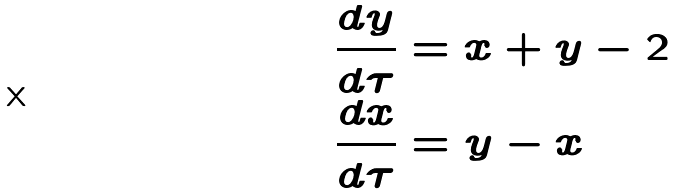Convert formula to latex. <formula><loc_0><loc_0><loc_500><loc_500>\frac { d y } { d \tau } & = x + y - 2 \\ \frac { d x } { d \tau } & = y - x</formula> 